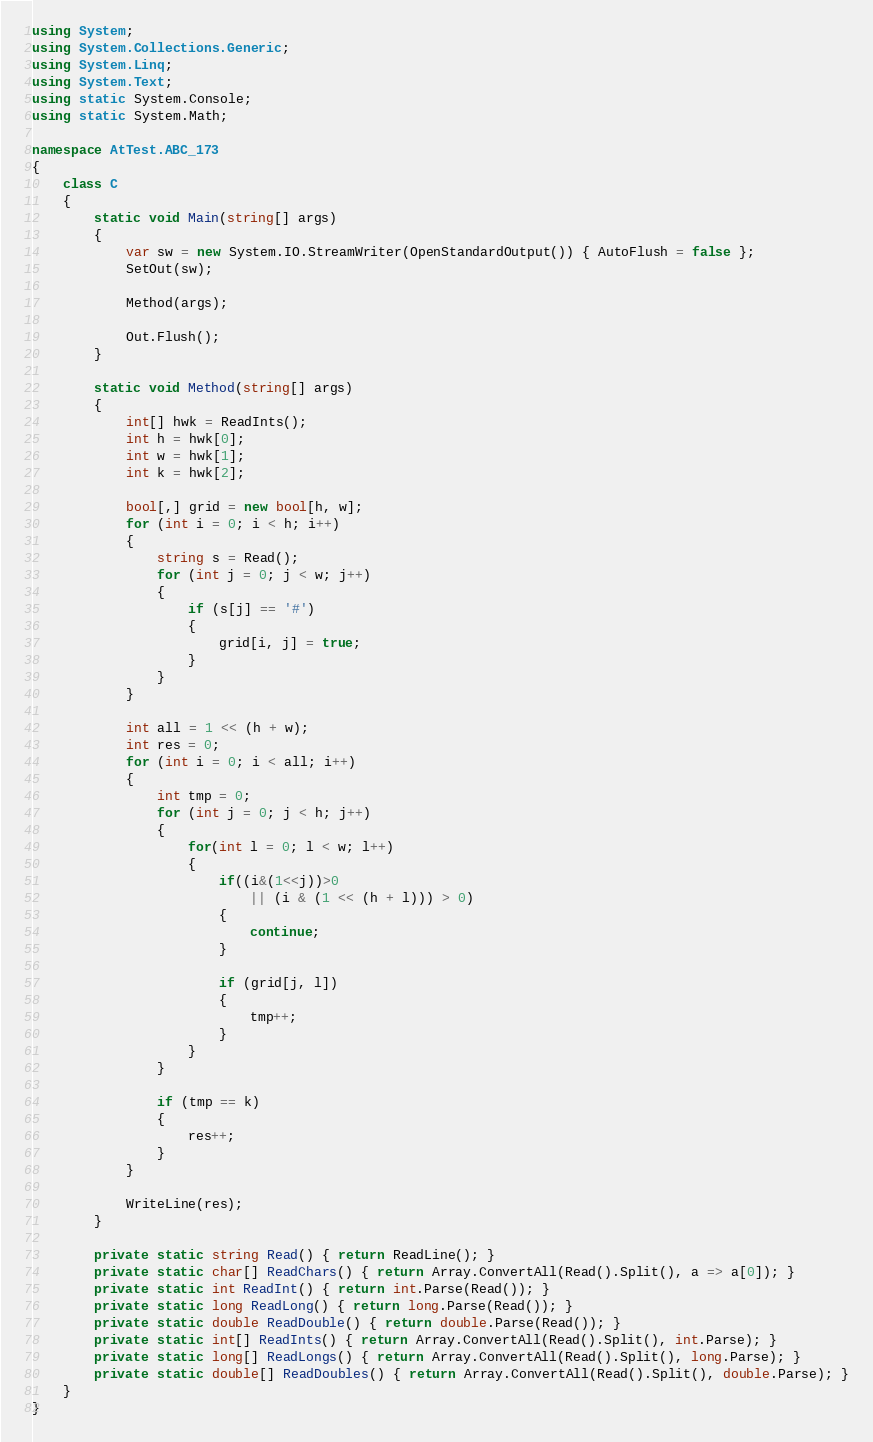<code> <loc_0><loc_0><loc_500><loc_500><_C#_>using System;
using System.Collections.Generic;
using System.Linq;
using System.Text;
using static System.Console;
using static System.Math;

namespace AtTest.ABC_173
{
    class C
    {
        static void Main(string[] args)
        {
            var sw = new System.IO.StreamWriter(OpenStandardOutput()) { AutoFlush = false };
            SetOut(sw);

            Method(args);

            Out.Flush();
        }

        static void Method(string[] args)
        {
            int[] hwk = ReadInts();
            int h = hwk[0];
            int w = hwk[1];
            int k = hwk[2];

            bool[,] grid = new bool[h, w];
            for (int i = 0; i < h; i++)
            {
                string s = Read();
                for (int j = 0; j < w; j++)
                {
                    if (s[j] == '#')
                    {
                        grid[i, j] = true;
                    }
                }
            }

            int all = 1 << (h + w);
            int res = 0;
            for (int i = 0; i < all; i++)
            {
                int tmp = 0;
                for (int j = 0; j < h; j++)
                {
                    for(int l = 0; l < w; l++)
                    {
                        if((i&(1<<j))>0
                            || (i & (1 << (h + l))) > 0)
                        {
                            continue;
                        }

                        if (grid[j, l])
                        {
                            tmp++;
                        }
                    }
                }

                if (tmp == k)
                {
                    res++;
                }
            }

            WriteLine(res);
        }

        private static string Read() { return ReadLine(); }
        private static char[] ReadChars() { return Array.ConvertAll(Read().Split(), a => a[0]); }
        private static int ReadInt() { return int.Parse(Read()); }
        private static long ReadLong() { return long.Parse(Read()); }
        private static double ReadDouble() { return double.Parse(Read()); }
        private static int[] ReadInts() { return Array.ConvertAll(Read().Split(), int.Parse); }
        private static long[] ReadLongs() { return Array.ConvertAll(Read().Split(), long.Parse); }
        private static double[] ReadDoubles() { return Array.ConvertAll(Read().Split(), double.Parse); }
    }
}
</code> 